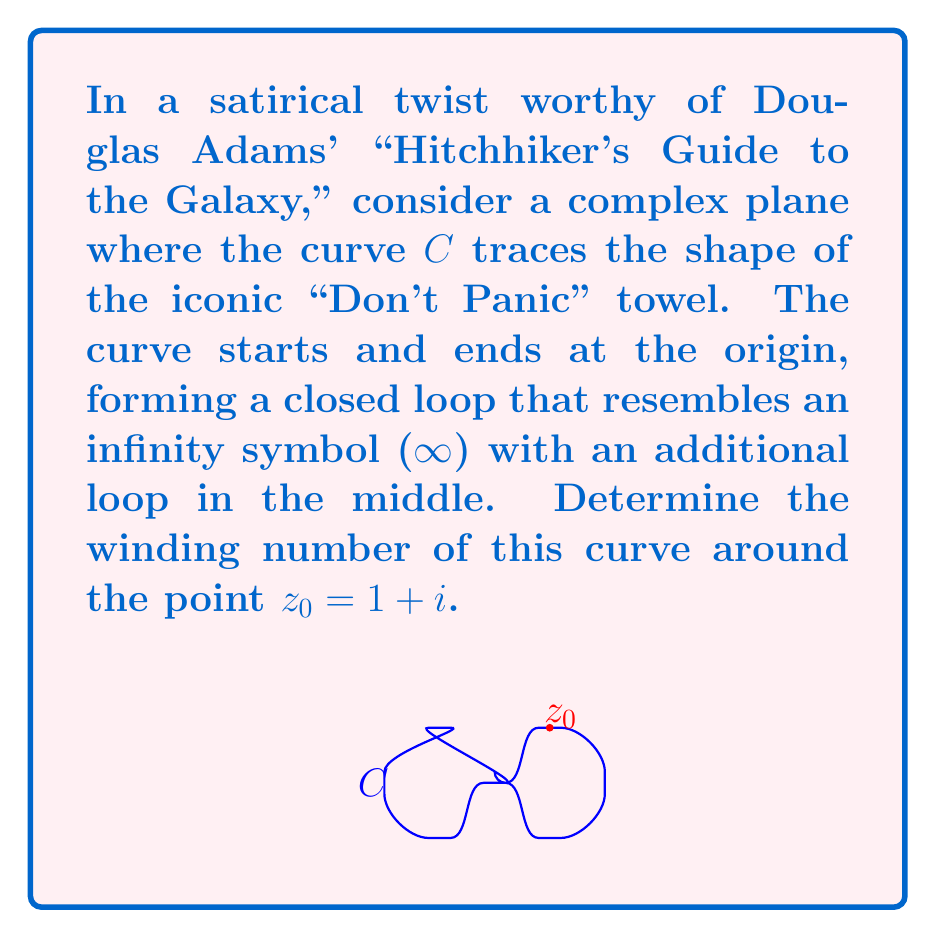Could you help me with this problem? To determine the winding number of the curve $C$ around the point $z_0 = 1+i$, we need to calculate how many times the curve encircles this point in the counterclockwise direction. Let's break this down step-by-step:

1) The winding number is given by the formula:

   $$n(C,z_0) = \frac{1}{2\pi i} \oint_C \frac{dz}{z-z_0}$$

2) In our case, the curve $C$ resembles an infinity symbol with an extra loop in the middle. We can think of it as three separate loops:

   a) The left loop of the infinity symbol
   b) The middle loop (the "Don't Panic" addition)
   c) The right loop of the infinity symbol

3) The point $z_0 = 1+i$ is located in the upper-right quadrant of the complex plane, inside the right loop of our curve.

4) Now, let's consider each loop:
   
   a) The left loop doesn't encircle $z_0$, so it contributes 0 to the winding number.
   b) The middle loop also doesn't encircle $z_0$, contributing 0.
   c) The right loop encircles $z_0$ once in the counterclockwise direction, contributing +1.

5) The total winding number is the sum of these contributions: 0 + 0 + 1 = 1.

This result tells us that, despite the curve's complicated shape reminiscent of a towel that's been through the improbability drive, it only winds around $z_0$ once in the positive (counterclockwise) direction.
Answer: The winding number of the curve $C$ around the point $z_0 = 1+i$ is 1. 